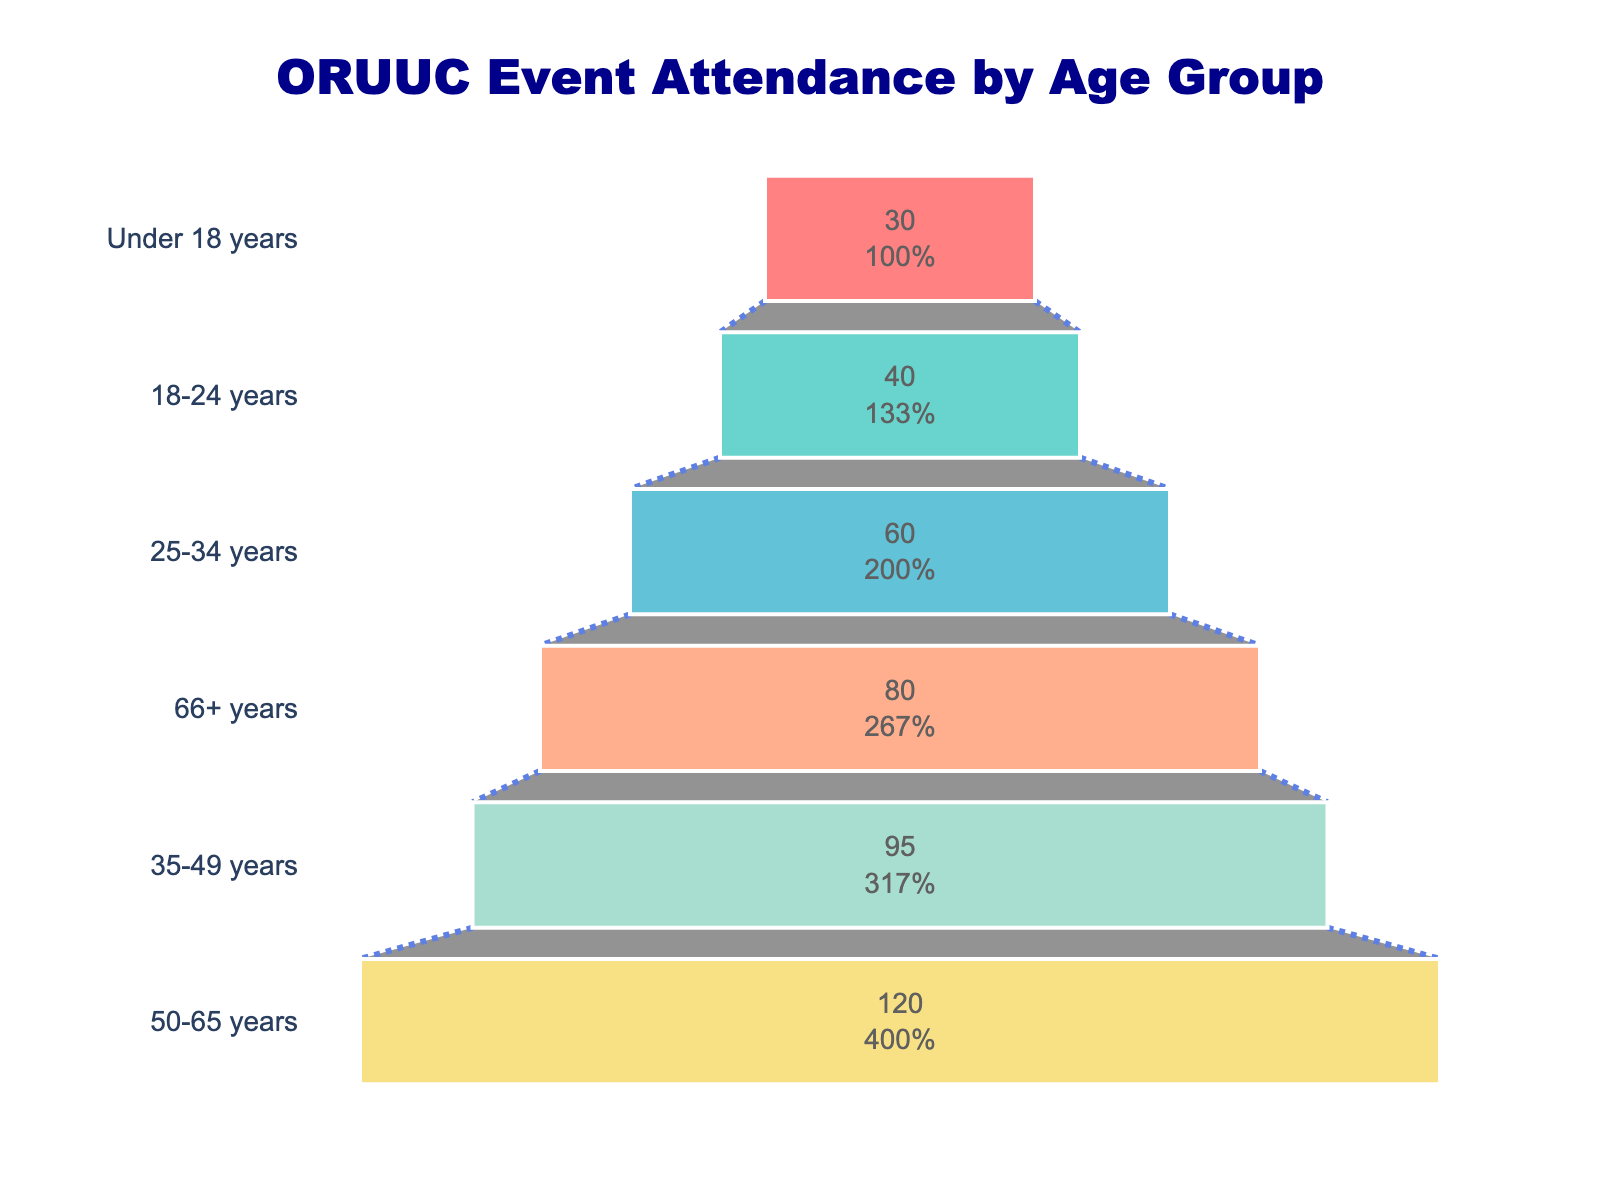What is the title of the plot? The title is located at the top center of the graph and is clearly distinguished by a larger and bold font.
Answer: ORUUC Event Attendance by Age Group How many age groups are represented in the funnel chart? Count the number of distinct age groups listed along the Y-axis of the funnel chart.
Answer: 6 Which age group has the highest attendance? Identify the age group at the widest part of the funnel, representing the largest value.
Answer: 50-65 years What is the attendance percentage of the 50-65 years age group relative to the initial total? The percentage is shown inside the section of the funnel chart corresponding to the 50-65 years age group.
Answer: 28% How does the attendance of the 25-34 years age group compare to that of the 18-24 years age group? Compare the heights of the sections of the funnel chart corresponding to these age groups. The 25-34 years group has 60 attendees and the 18-24 years group has 40.
Answer: 50% higher What are the colors used to represent different age groups in the chart? Identify the colors by looking at each segment of the funnel.
Answer: Shades of red, cyan, blue, salmon, light green, and yellow What is the combined attendance of the 18-24 years and under 18 years age groups? Add the attendance of the two age groups: 40 (18-24) + 30 (Under 18).
Answer: 70 Which age group has an attendance close to the midpoint value of all groups' attendances combined? Calculate the total attendance and find the midpoint, then identify the group closest to this value. Total = 120 + 95 + 80 + 60 + 40 + 30 = 425; Midpoint = 425/2 = 212.5. Age groups are 50-65, 35-49, 66+, so 66+ years (80) is closest but 35-49 years (95) is slightly closer.
Answer: 35-49 years 